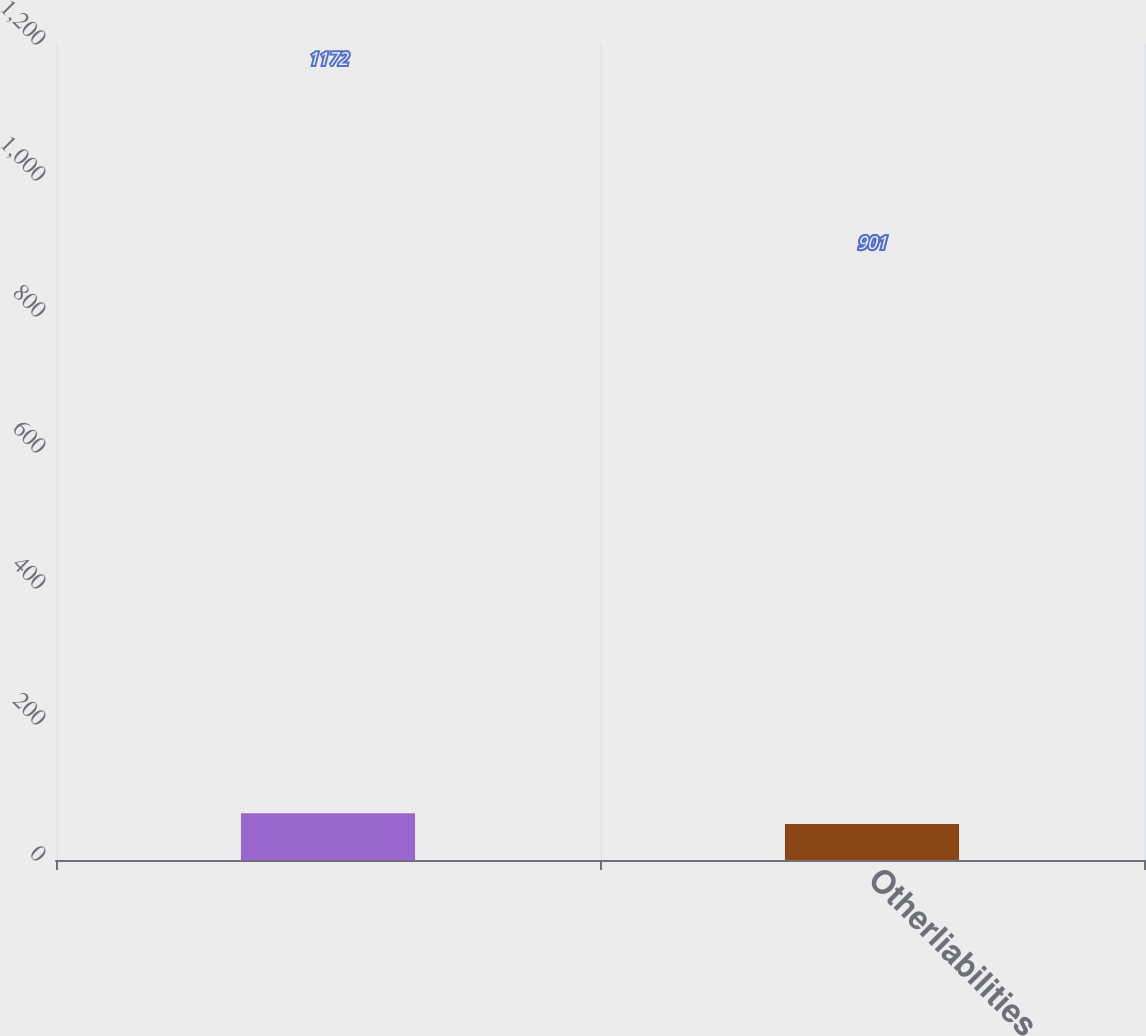Convert chart. <chart><loc_0><loc_0><loc_500><loc_500><bar_chart><ecel><fcel>Otherliabilities<nl><fcel>1172<fcel>901<nl></chart> 